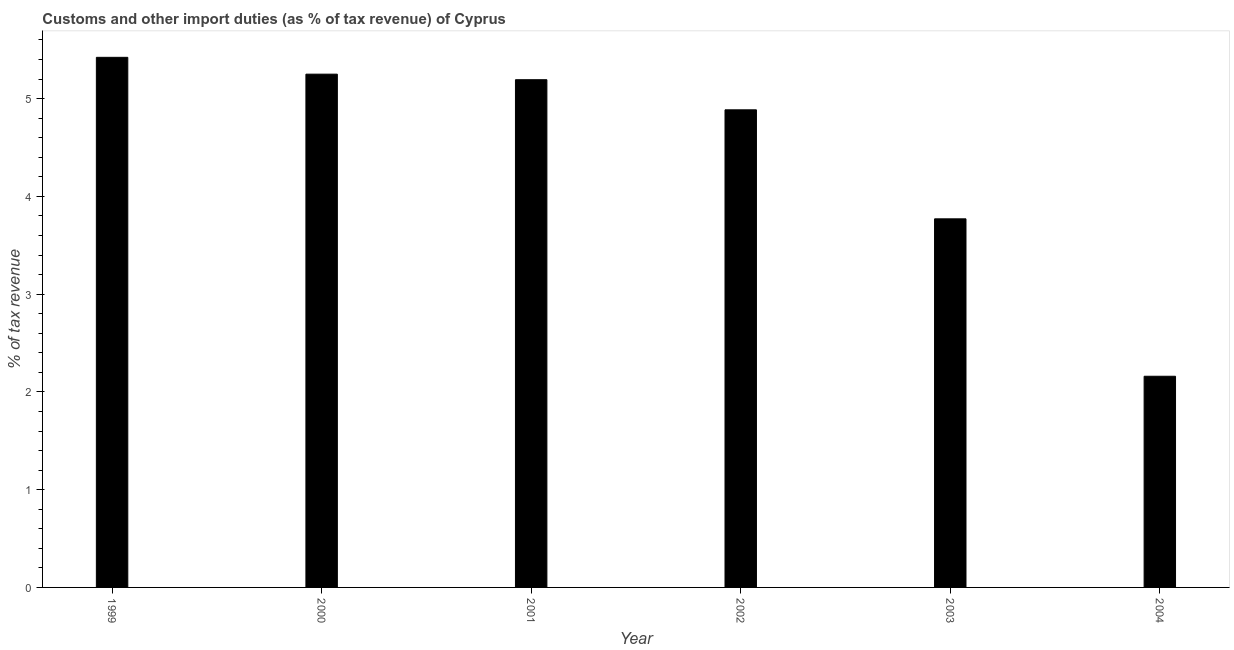Does the graph contain any zero values?
Keep it short and to the point. No. What is the title of the graph?
Your answer should be compact. Customs and other import duties (as % of tax revenue) of Cyprus. What is the label or title of the X-axis?
Provide a short and direct response. Year. What is the label or title of the Y-axis?
Give a very brief answer. % of tax revenue. What is the customs and other import duties in 2000?
Give a very brief answer. 5.25. Across all years, what is the maximum customs and other import duties?
Provide a short and direct response. 5.42. Across all years, what is the minimum customs and other import duties?
Provide a succinct answer. 2.16. In which year was the customs and other import duties maximum?
Provide a succinct answer. 1999. What is the sum of the customs and other import duties?
Keep it short and to the point. 26.68. What is the difference between the customs and other import duties in 2000 and 2004?
Your answer should be compact. 3.09. What is the average customs and other import duties per year?
Provide a succinct answer. 4.45. What is the median customs and other import duties?
Offer a terse response. 5.04. Do a majority of the years between 2003 and 2001 (inclusive) have customs and other import duties greater than 2.4 %?
Provide a short and direct response. Yes. What is the ratio of the customs and other import duties in 2001 to that in 2002?
Provide a short and direct response. 1.06. Is the difference between the customs and other import duties in 2002 and 2003 greater than the difference between any two years?
Ensure brevity in your answer.  No. What is the difference between the highest and the second highest customs and other import duties?
Offer a terse response. 0.17. Is the sum of the customs and other import duties in 2000 and 2003 greater than the maximum customs and other import duties across all years?
Ensure brevity in your answer.  Yes. What is the difference between the highest and the lowest customs and other import duties?
Offer a terse response. 3.26. How many bars are there?
Offer a terse response. 6. Are the values on the major ticks of Y-axis written in scientific E-notation?
Offer a terse response. No. What is the % of tax revenue in 1999?
Make the answer very short. 5.42. What is the % of tax revenue of 2000?
Ensure brevity in your answer.  5.25. What is the % of tax revenue of 2001?
Offer a very short reply. 5.19. What is the % of tax revenue of 2002?
Your response must be concise. 4.89. What is the % of tax revenue in 2003?
Your answer should be very brief. 3.77. What is the % of tax revenue of 2004?
Your answer should be compact. 2.16. What is the difference between the % of tax revenue in 1999 and 2000?
Offer a very short reply. 0.17. What is the difference between the % of tax revenue in 1999 and 2001?
Offer a very short reply. 0.23. What is the difference between the % of tax revenue in 1999 and 2002?
Your response must be concise. 0.54. What is the difference between the % of tax revenue in 1999 and 2003?
Provide a short and direct response. 1.65. What is the difference between the % of tax revenue in 1999 and 2004?
Your answer should be very brief. 3.26. What is the difference between the % of tax revenue in 2000 and 2001?
Keep it short and to the point. 0.06. What is the difference between the % of tax revenue in 2000 and 2002?
Offer a very short reply. 0.36. What is the difference between the % of tax revenue in 2000 and 2003?
Your answer should be very brief. 1.48. What is the difference between the % of tax revenue in 2000 and 2004?
Provide a succinct answer. 3.09. What is the difference between the % of tax revenue in 2001 and 2002?
Make the answer very short. 0.31. What is the difference between the % of tax revenue in 2001 and 2003?
Provide a succinct answer. 1.42. What is the difference between the % of tax revenue in 2001 and 2004?
Your answer should be compact. 3.03. What is the difference between the % of tax revenue in 2002 and 2003?
Your response must be concise. 1.12. What is the difference between the % of tax revenue in 2002 and 2004?
Your answer should be very brief. 2.73. What is the difference between the % of tax revenue in 2003 and 2004?
Your response must be concise. 1.61. What is the ratio of the % of tax revenue in 1999 to that in 2000?
Your answer should be very brief. 1.03. What is the ratio of the % of tax revenue in 1999 to that in 2001?
Make the answer very short. 1.04. What is the ratio of the % of tax revenue in 1999 to that in 2002?
Make the answer very short. 1.11. What is the ratio of the % of tax revenue in 1999 to that in 2003?
Give a very brief answer. 1.44. What is the ratio of the % of tax revenue in 1999 to that in 2004?
Ensure brevity in your answer.  2.51. What is the ratio of the % of tax revenue in 2000 to that in 2001?
Your answer should be compact. 1.01. What is the ratio of the % of tax revenue in 2000 to that in 2002?
Provide a short and direct response. 1.07. What is the ratio of the % of tax revenue in 2000 to that in 2003?
Offer a very short reply. 1.39. What is the ratio of the % of tax revenue in 2000 to that in 2004?
Ensure brevity in your answer.  2.43. What is the ratio of the % of tax revenue in 2001 to that in 2002?
Your response must be concise. 1.06. What is the ratio of the % of tax revenue in 2001 to that in 2003?
Provide a succinct answer. 1.38. What is the ratio of the % of tax revenue in 2001 to that in 2004?
Your response must be concise. 2.4. What is the ratio of the % of tax revenue in 2002 to that in 2003?
Give a very brief answer. 1.3. What is the ratio of the % of tax revenue in 2002 to that in 2004?
Provide a short and direct response. 2.26. What is the ratio of the % of tax revenue in 2003 to that in 2004?
Your response must be concise. 1.75. 